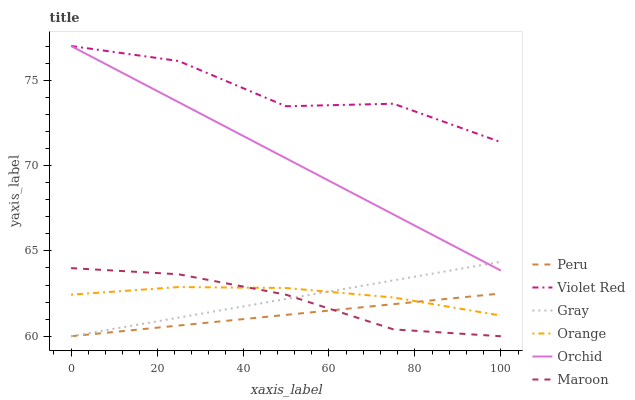Does Maroon have the minimum area under the curve?
Answer yes or no. No. Does Maroon have the maximum area under the curve?
Answer yes or no. No. Is Maroon the smoothest?
Answer yes or no. No. Is Maroon the roughest?
Answer yes or no. No. Does Violet Red have the lowest value?
Answer yes or no. No. Does Maroon have the highest value?
Answer yes or no. No. Is Peru less than Orchid?
Answer yes or no. Yes. Is Orchid greater than Orange?
Answer yes or no. Yes. Does Peru intersect Orchid?
Answer yes or no. No. 